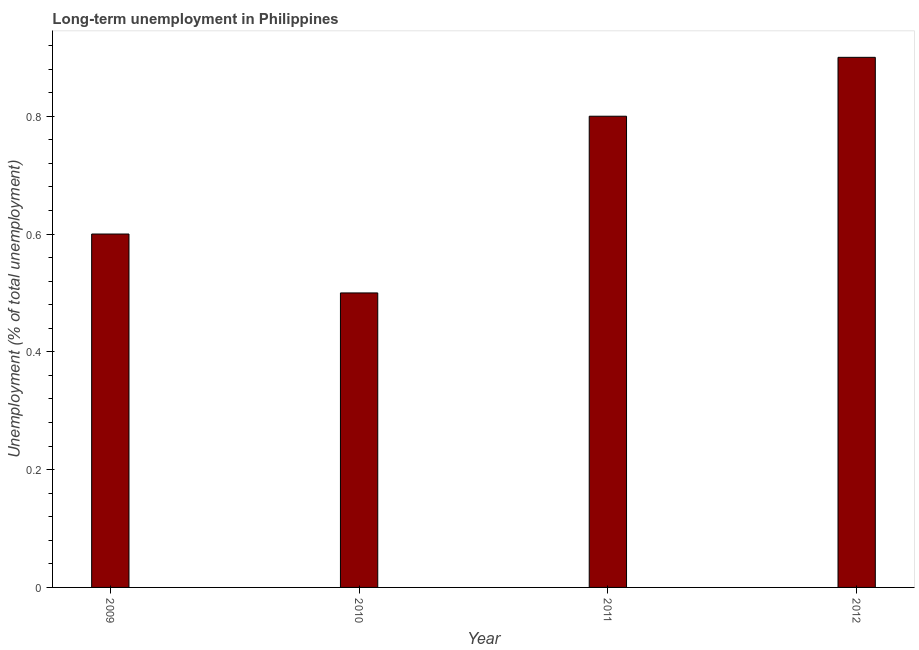Does the graph contain grids?
Keep it short and to the point. No. What is the title of the graph?
Your response must be concise. Long-term unemployment in Philippines. What is the label or title of the X-axis?
Keep it short and to the point. Year. What is the label or title of the Y-axis?
Keep it short and to the point. Unemployment (% of total unemployment). What is the long-term unemployment in 2012?
Offer a very short reply. 0.9. Across all years, what is the maximum long-term unemployment?
Keep it short and to the point. 0.9. Across all years, what is the minimum long-term unemployment?
Make the answer very short. 0.5. In which year was the long-term unemployment maximum?
Your response must be concise. 2012. What is the sum of the long-term unemployment?
Make the answer very short. 2.8. What is the difference between the long-term unemployment in 2010 and 2012?
Your response must be concise. -0.4. What is the median long-term unemployment?
Your answer should be compact. 0.7. What is the ratio of the long-term unemployment in 2011 to that in 2012?
Make the answer very short. 0.89. Is the long-term unemployment in 2010 less than that in 2011?
Provide a short and direct response. Yes. What is the difference between the highest and the lowest long-term unemployment?
Offer a very short reply. 0.4. How many bars are there?
Offer a terse response. 4. How many years are there in the graph?
Keep it short and to the point. 4. What is the difference between two consecutive major ticks on the Y-axis?
Ensure brevity in your answer.  0.2. What is the Unemployment (% of total unemployment) in 2009?
Keep it short and to the point. 0.6. What is the Unemployment (% of total unemployment) of 2010?
Your answer should be very brief. 0.5. What is the Unemployment (% of total unemployment) in 2011?
Provide a succinct answer. 0.8. What is the Unemployment (% of total unemployment) in 2012?
Your response must be concise. 0.9. What is the difference between the Unemployment (% of total unemployment) in 2009 and 2010?
Your response must be concise. 0.1. What is the difference between the Unemployment (% of total unemployment) in 2009 and 2011?
Your response must be concise. -0.2. What is the difference between the Unemployment (% of total unemployment) in 2009 and 2012?
Ensure brevity in your answer.  -0.3. What is the difference between the Unemployment (% of total unemployment) in 2010 and 2011?
Give a very brief answer. -0.3. What is the ratio of the Unemployment (% of total unemployment) in 2009 to that in 2011?
Give a very brief answer. 0.75. What is the ratio of the Unemployment (% of total unemployment) in 2009 to that in 2012?
Ensure brevity in your answer.  0.67. What is the ratio of the Unemployment (% of total unemployment) in 2010 to that in 2011?
Keep it short and to the point. 0.62. What is the ratio of the Unemployment (% of total unemployment) in 2010 to that in 2012?
Your response must be concise. 0.56. What is the ratio of the Unemployment (% of total unemployment) in 2011 to that in 2012?
Offer a very short reply. 0.89. 